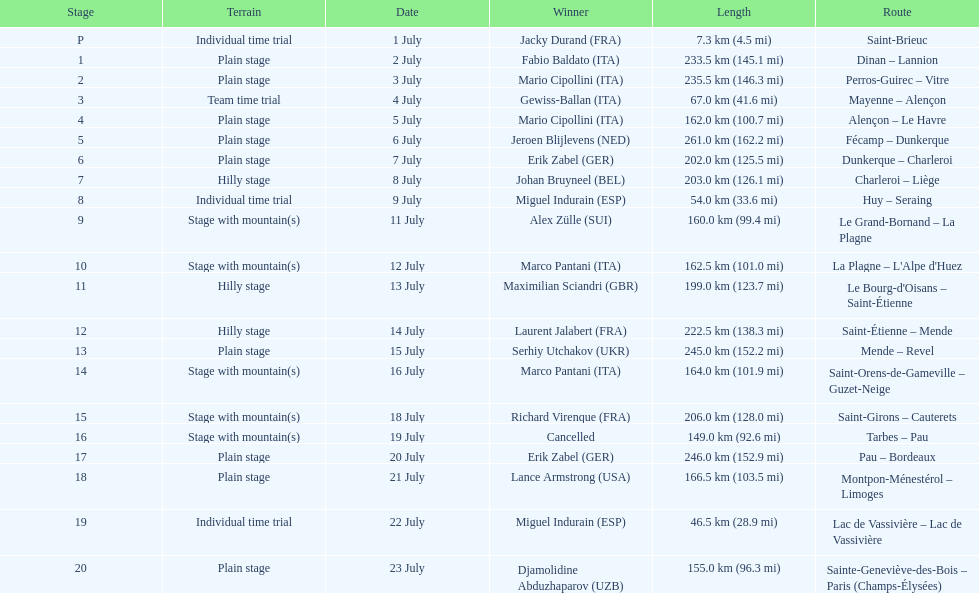How many routes have below 100 km total? 4. 